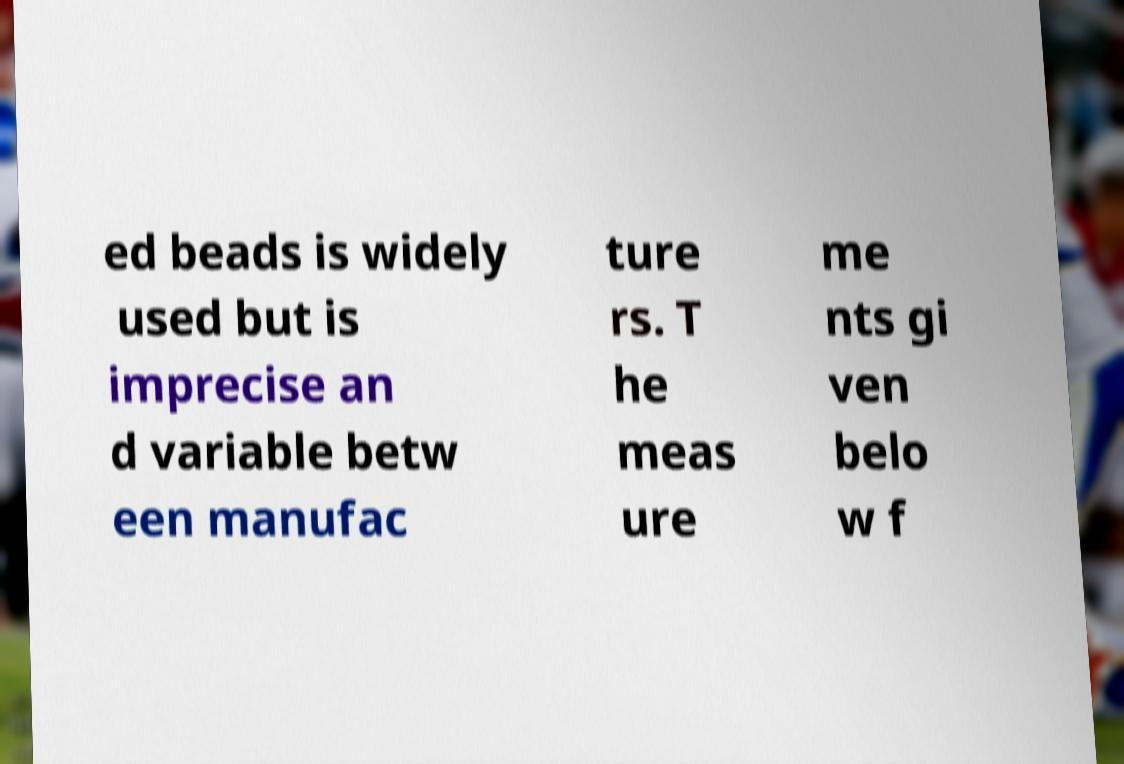Please identify and transcribe the text found in this image. ed beads is widely used but is imprecise an d variable betw een manufac ture rs. T he meas ure me nts gi ven belo w f 